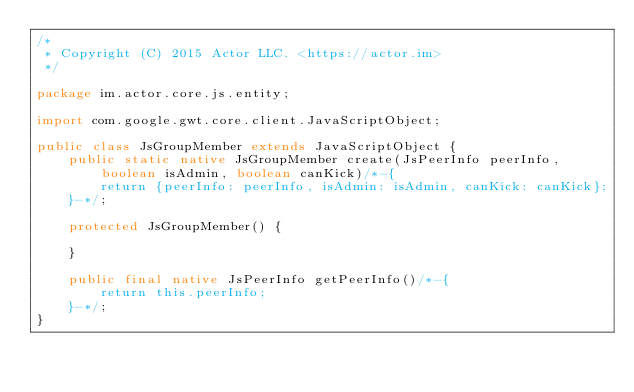<code> <loc_0><loc_0><loc_500><loc_500><_Java_>/*
 * Copyright (C) 2015 Actor LLC. <https://actor.im>
 */

package im.actor.core.js.entity;

import com.google.gwt.core.client.JavaScriptObject;

public class JsGroupMember extends JavaScriptObject {
    public static native JsGroupMember create(JsPeerInfo peerInfo, boolean isAdmin, boolean canKick)/*-{
        return {peerInfo: peerInfo, isAdmin: isAdmin, canKick: canKick};
    }-*/;

    protected JsGroupMember() {

    }

    public final native JsPeerInfo getPeerInfo()/*-{
        return this.peerInfo;
    }-*/;
}</code> 